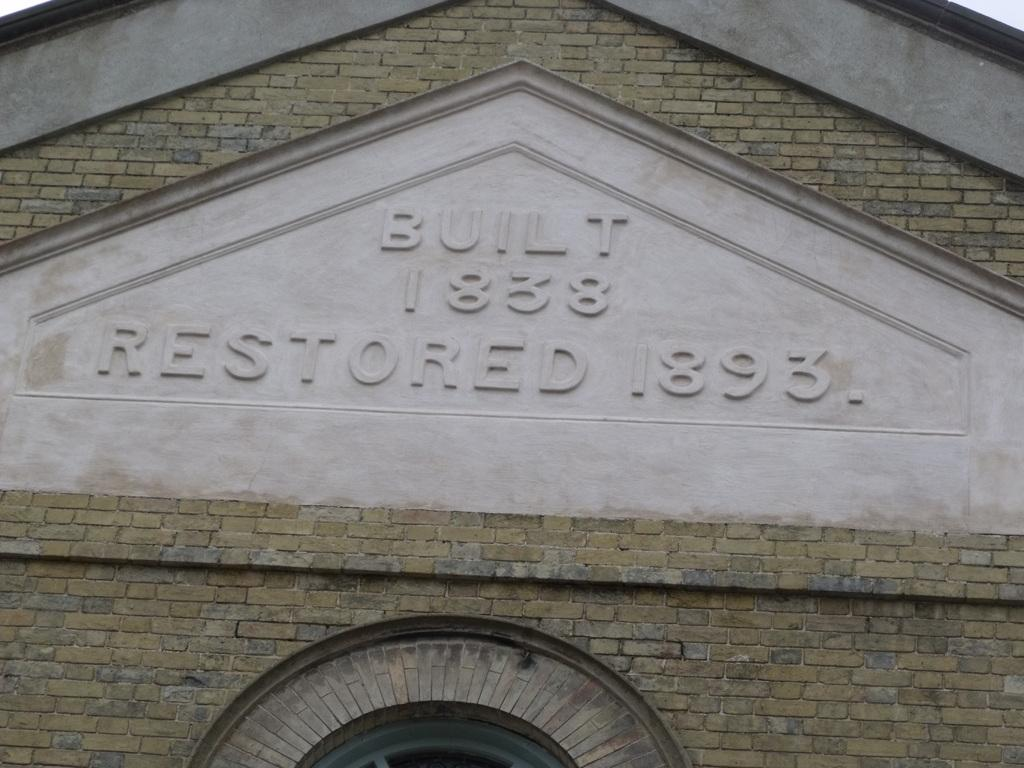What type of structure is present in the image? There is a building in the image. What else can be seen in the image besides the building? There is text visible in the image. What material does the building appear to be made of? The building appears to be made of bricks. Can you tell me where the river flows in the image? There is no river present in the image. What type of quiver is being used by the division in the image? There is no quiver or division present in the image. 